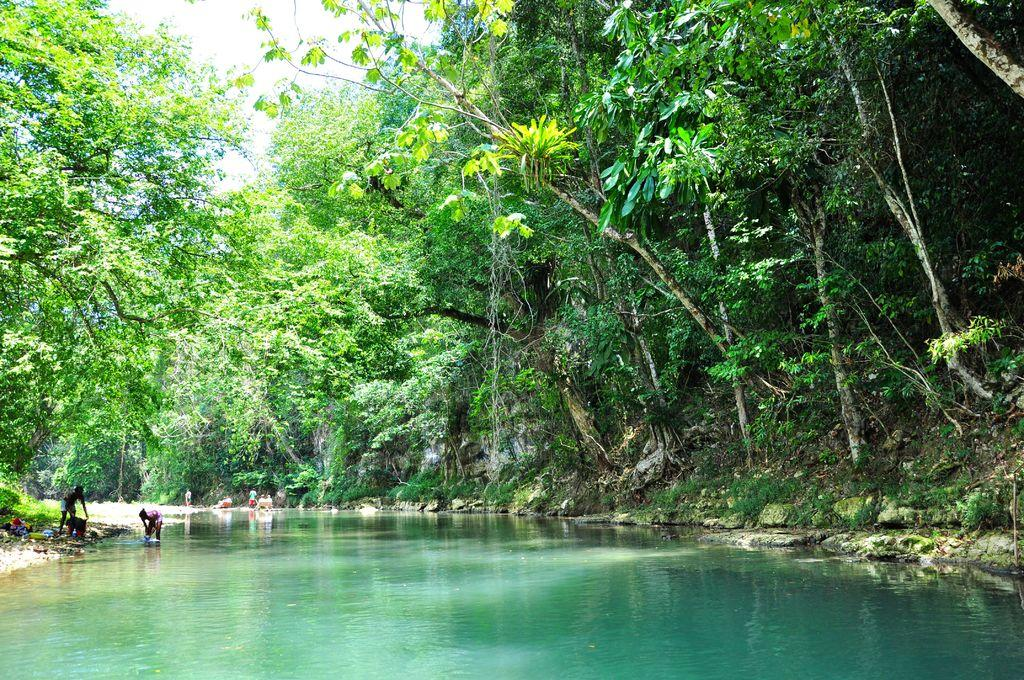What is the main feature in the middle of the image? There is a canal in the middle of the image. What can be seen on either side of the canal? Trees are present on either side of the canal. What activity is taking place in the canal? There are people washing clothes in the canal. What type of substance can be tasted in the image? There is no indication of any substance that can be tasted in the image. 